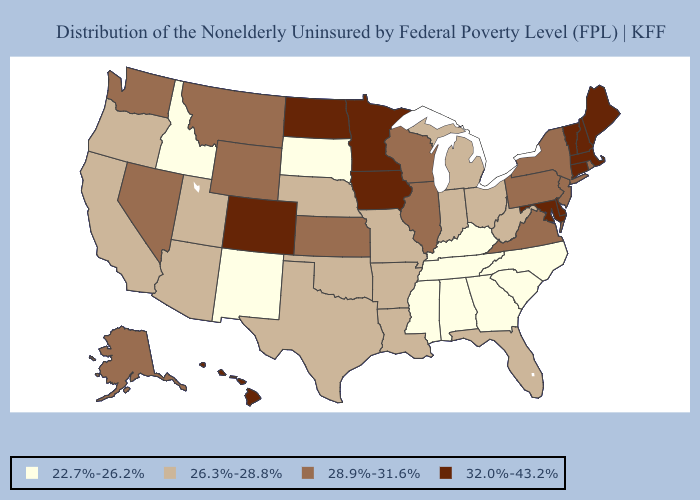What is the highest value in the USA?
Be succinct. 32.0%-43.2%. Name the states that have a value in the range 32.0%-43.2%?
Short answer required. Colorado, Connecticut, Delaware, Hawaii, Iowa, Maine, Maryland, Massachusetts, Minnesota, New Hampshire, North Dakota, Vermont. What is the value of Arkansas?
Keep it brief. 26.3%-28.8%. Does Idaho have the lowest value in the USA?
Give a very brief answer. Yes. Name the states that have a value in the range 32.0%-43.2%?
Give a very brief answer. Colorado, Connecticut, Delaware, Hawaii, Iowa, Maine, Maryland, Massachusetts, Minnesota, New Hampshire, North Dakota, Vermont. What is the highest value in the West ?
Give a very brief answer. 32.0%-43.2%. Name the states that have a value in the range 28.9%-31.6%?
Keep it brief. Alaska, Illinois, Kansas, Montana, Nevada, New Jersey, New York, Pennsylvania, Rhode Island, Virginia, Washington, Wisconsin, Wyoming. What is the value of New Hampshire?
Short answer required. 32.0%-43.2%. Is the legend a continuous bar?
Answer briefly. No. Name the states that have a value in the range 32.0%-43.2%?
Keep it brief. Colorado, Connecticut, Delaware, Hawaii, Iowa, Maine, Maryland, Massachusetts, Minnesota, New Hampshire, North Dakota, Vermont. Does the first symbol in the legend represent the smallest category?
Answer briefly. Yes. Which states hav the highest value in the South?
Keep it brief. Delaware, Maryland. Name the states that have a value in the range 22.7%-26.2%?
Keep it brief. Alabama, Georgia, Idaho, Kentucky, Mississippi, New Mexico, North Carolina, South Carolina, South Dakota, Tennessee. What is the value of Montana?
Quick response, please. 28.9%-31.6%. Name the states that have a value in the range 22.7%-26.2%?
Be succinct. Alabama, Georgia, Idaho, Kentucky, Mississippi, New Mexico, North Carolina, South Carolina, South Dakota, Tennessee. 